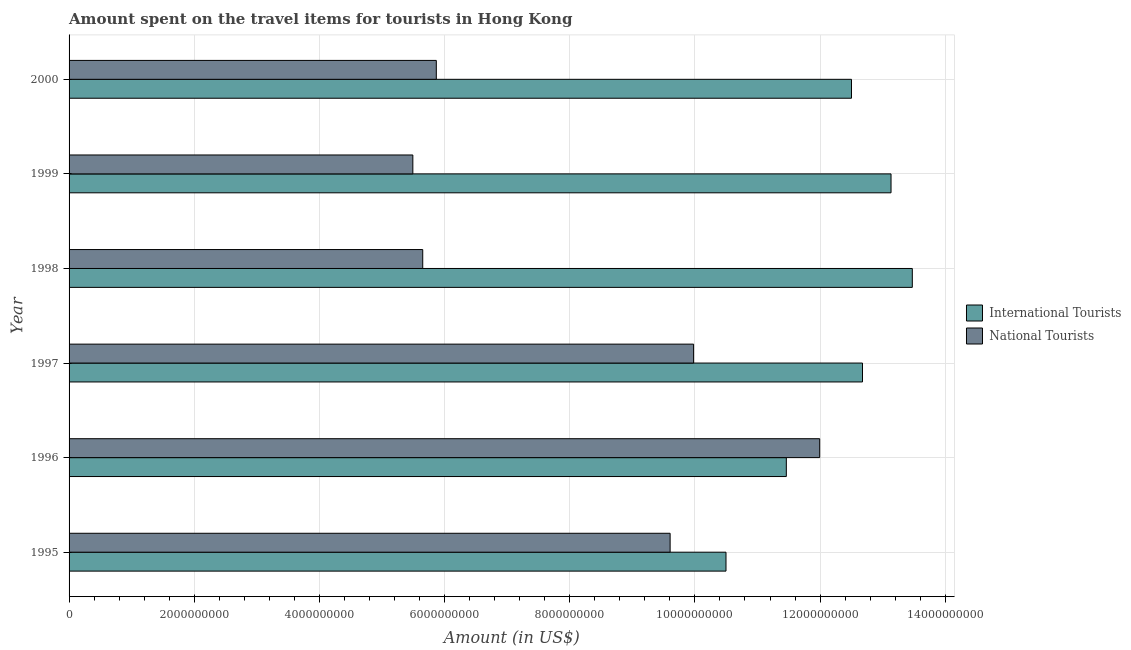Are the number of bars on each tick of the Y-axis equal?
Provide a succinct answer. Yes. How many bars are there on the 4th tick from the top?
Give a very brief answer. 2. What is the label of the 6th group of bars from the top?
Your answer should be very brief. 1995. What is the amount spent on travel items of international tourists in 1999?
Your response must be concise. 1.31e+1. Across all years, what is the maximum amount spent on travel items of national tourists?
Ensure brevity in your answer.  1.20e+1. Across all years, what is the minimum amount spent on travel items of national tourists?
Your answer should be very brief. 5.49e+09. In which year was the amount spent on travel items of national tourists maximum?
Your answer should be compact. 1996. What is the total amount spent on travel items of national tourists in the graph?
Offer a terse response. 4.86e+1. What is the difference between the amount spent on travel items of international tourists in 1999 and that in 2000?
Ensure brevity in your answer.  6.32e+08. What is the difference between the amount spent on travel items of national tourists in 1997 and the amount spent on travel items of international tourists in 2000?
Your answer should be compact. -2.52e+09. What is the average amount spent on travel items of international tourists per year?
Offer a terse response. 1.23e+1. In the year 2000, what is the difference between the amount spent on travel items of national tourists and amount spent on travel items of international tourists?
Offer a very short reply. -6.63e+09. What is the ratio of the amount spent on travel items of international tourists in 1997 to that in 1998?
Your answer should be compact. 0.94. Is the difference between the amount spent on travel items of national tourists in 1998 and 2000 greater than the difference between the amount spent on travel items of international tourists in 1998 and 2000?
Provide a succinct answer. No. What is the difference between the highest and the second highest amount spent on travel items of national tourists?
Provide a succinct answer. 2.02e+09. What is the difference between the highest and the lowest amount spent on travel items of national tourists?
Your response must be concise. 6.50e+09. In how many years, is the amount spent on travel items of international tourists greater than the average amount spent on travel items of international tourists taken over all years?
Make the answer very short. 4. What does the 2nd bar from the top in 1995 represents?
Keep it short and to the point. International Tourists. What does the 1st bar from the bottom in 1995 represents?
Keep it short and to the point. International Tourists. Are all the bars in the graph horizontal?
Your answer should be compact. Yes. How many years are there in the graph?
Offer a terse response. 6. What is the difference between two consecutive major ticks on the X-axis?
Your answer should be very brief. 2.00e+09. Are the values on the major ticks of X-axis written in scientific E-notation?
Your answer should be compact. No. Does the graph contain any zero values?
Offer a very short reply. No. Does the graph contain grids?
Make the answer very short. Yes. Where does the legend appear in the graph?
Provide a succinct answer. Center right. What is the title of the graph?
Offer a terse response. Amount spent on the travel items for tourists in Hong Kong. What is the label or title of the Y-axis?
Your response must be concise. Year. What is the Amount (in US$) of International Tourists in 1995?
Provide a short and direct response. 1.05e+1. What is the Amount (in US$) of National Tourists in 1995?
Keep it short and to the point. 9.60e+09. What is the Amount (in US$) in International Tourists in 1996?
Give a very brief answer. 1.15e+1. What is the Amount (in US$) in National Tourists in 1996?
Provide a succinct answer. 1.20e+1. What is the Amount (in US$) in International Tourists in 1997?
Your response must be concise. 1.27e+1. What is the Amount (in US$) of National Tourists in 1997?
Your answer should be very brief. 9.98e+09. What is the Amount (in US$) of International Tourists in 1998?
Provide a short and direct response. 1.35e+1. What is the Amount (in US$) of National Tourists in 1998?
Keep it short and to the point. 5.65e+09. What is the Amount (in US$) of International Tourists in 1999?
Your response must be concise. 1.31e+1. What is the Amount (in US$) in National Tourists in 1999?
Keep it short and to the point. 5.49e+09. What is the Amount (in US$) in International Tourists in 2000?
Your response must be concise. 1.25e+1. What is the Amount (in US$) in National Tourists in 2000?
Your answer should be very brief. 5.87e+09. Across all years, what is the maximum Amount (in US$) of International Tourists?
Ensure brevity in your answer.  1.35e+1. Across all years, what is the maximum Amount (in US$) in National Tourists?
Give a very brief answer. 1.20e+1. Across all years, what is the minimum Amount (in US$) in International Tourists?
Your answer should be compact. 1.05e+1. Across all years, what is the minimum Amount (in US$) of National Tourists?
Provide a succinct answer. 5.49e+09. What is the total Amount (in US$) of International Tourists in the graph?
Provide a short and direct response. 7.37e+1. What is the total Amount (in US$) of National Tourists in the graph?
Keep it short and to the point. 4.86e+1. What is the difference between the Amount (in US$) of International Tourists in 1995 and that in 1996?
Provide a succinct answer. -9.64e+08. What is the difference between the Amount (in US$) of National Tourists in 1995 and that in 1996?
Provide a succinct answer. -2.39e+09. What is the difference between the Amount (in US$) of International Tourists in 1995 and that in 1997?
Your response must be concise. -2.18e+09. What is the difference between the Amount (in US$) in National Tourists in 1995 and that in 1997?
Ensure brevity in your answer.  -3.75e+08. What is the difference between the Amount (in US$) in International Tourists in 1995 and that in 1998?
Provide a succinct answer. -2.98e+09. What is the difference between the Amount (in US$) in National Tourists in 1995 and that in 1998?
Offer a very short reply. 3.95e+09. What is the difference between the Amount (in US$) of International Tourists in 1995 and that in 1999?
Your response must be concise. -2.64e+09. What is the difference between the Amount (in US$) in National Tourists in 1995 and that in 1999?
Offer a very short reply. 4.11e+09. What is the difference between the Amount (in US$) of International Tourists in 1995 and that in 2000?
Provide a short and direct response. -2.00e+09. What is the difference between the Amount (in US$) in National Tourists in 1995 and that in 2000?
Make the answer very short. 3.74e+09. What is the difference between the Amount (in US$) of International Tourists in 1996 and that in 1997?
Make the answer very short. -1.22e+09. What is the difference between the Amount (in US$) of National Tourists in 1996 and that in 1997?
Your response must be concise. 2.02e+09. What is the difference between the Amount (in US$) of International Tourists in 1996 and that in 1998?
Make the answer very short. -2.01e+09. What is the difference between the Amount (in US$) of National Tourists in 1996 and that in 1998?
Your answer should be compact. 6.34e+09. What is the difference between the Amount (in US$) of International Tourists in 1996 and that in 1999?
Offer a very short reply. -1.67e+09. What is the difference between the Amount (in US$) in National Tourists in 1996 and that in 1999?
Your answer should be compact. 6.50e+09. What is the difference between the Amount (in US$) in International Tourists in 1996 and that in 2000?
Provide a succinct answer. -1.04e+09. What is the difference between the Amount (in US$) in National Tourists in 1996 and that in 2000?
Offer a very short reply. 6.13e+09. What is the difference between the Amount (in US$) in International Tourists in 1997 and that in 1998?
Provide a short and direct response. -7.96e+08. What is the difference between the Amount (in US$) in National Tourists in 1997 and that in 1998?
Your response must be concise. 4.33e+09. What is the difference between the Amount (in US$) in International Tourists in 1997 and that in 1999?
Provide a short and direct response. -4.56e+08. What is the difference between the Amount (in US$) in National Tourists in 1997 and that in 1999?
Keep it short and to the point. 4.49e+09. What is the difference between the Amount (in US$) in International Tourists in 1997 and that in 2000?
Offer a very short reply. 1.76e+08. What is the difference between the Amount (in US$) in National Tourists in 1997 and that in 2000?
Keep it short and to the point. 4.11e+09. What is the difference between the Amount (in US$) in International Tourists in 1998 and that in 1999?
Offer a very short reply. 3.40e+08. What is the difference between the Amount (in US$) in National Tourists in 1998 and that in 1999?
Make the answer very short. 1.58e+08. What is the difference between the Amount (in US$) in International Tourists in 1998 and that in 2000?
Provide a succinct answer. 9.72e+08. What is the difference between the Amount (in US$) of National Tourists in 1998 and that in 2000?
Ensure brevity in your answer.  -2.17e+08. What is the difference between the Amount (in US$) in International Tourists in 1999 and that in 2000?
Give a very brief answer. 6.32e+08. What is the difference between the Amount (in US$) of National Tourists in 1999 and that in 2000?
Your response must be concise. -3.75e+08. What is the difference between the Amount (in US$) in International Tourists in 1995 and the Amount (in US$) in National Tourists in 1996?
Make the answer very short. -1.50e+09. What is the difference between the Amount (in US$) in International Tourists in 1995 and the Amount (in US$) in National Tourists in 1997?
Keep it short and to the point. 5.18e+08. What is the difference between the Amount (in US$) in International Tourists in 1995 and the Amount (in US$) in National Tourists in 1998?
Give a very brief answer. 4.85e+09. What is the difference between the Amount (in US$) of International Tourists in 1995 and the Amount (in US$) of National Tourists in 1999?
Provide a short and direct response. 5.00e+09. What is the difference between the Amount (in US$) of International Tourists in 1995 and the Amount (in US$) of National Tourists in 2000?
Your response must be concise. 4.63e+09. What is the difference between the Amount (in US$) in International Tourists in 1996 and the Amount (in US$) in National Tourists in 1997?
Make the answer very short. 1.48e+09. What is the difference between the Amount (in US$) of International Tourists in 1996 and the Amount (in US$) of National Tourists in 1998?
Ensure brevity in your answer.  5.81e+09. What is the difference between the Amount (in US$) of International Tourists in 1996 and the Amount (in US$) of National Tourists in 1999?
Ensure brevity in your answer.  5.97e+09. What is the difference between the Amount (in US$) of International Tourists in 1996 and the Amount (in US$) of National Tourists in 2000?
Your answer should be compact. 5.59e+09. What is the difference between the Amount (in US$) in International Tourists in 1997 and the Amount (in US$) in National Tourists in 1998?
Offer a terse response. 7.03e+09. What is the difference between the Amount (in US$) of International Tourists in 1997 and the Amount (in US$) of National Tourists in 1999?
Provide a short and direct response. 7.18e+09. What is the difference between the Amount (in US$) of International Tourists in 1997 and the Amount (in US$) of National Tourists in 2000?
Provide a succinct answer. 6.81e+09. What is the difference between the Amount (in US$) of International Tourists in 1998 and the Amount (in US$) of National Tourists in 1999?
Offer a terse response. 7.98e+09. What is the difference between the Amount (in US$) in International Tourists in 1998 and the Amount (in US$) in National Tourists in 2000?
Give a very brief answer. 7.61e+09. What is the difference between the Amount (in US$) in International Tourists in 1999 and the Amount (in US$) in National Tourists in 2000?
Provide a succinct answer. 7.27e+09. What is the average Amount (in US$) in International Tourists per year?
Keep it short and to the point. 1.23e+1. What is the average Amount (in US$) of National Tourists per year?
Offer a very short reply. 8.10e+09. In the year 1995, what is the difference between the Amount (in US$) of International Tourists and Amount (in US$) of National Tourists?
Provide a succinct answer. 8.93e+08. In the year 1996, what is the difference between the Amount (in US$) of International Tourists and Amount (in US$) of National Tourists?
Offer a very short reply. -5.33e+08. In the year 1997, what is the difference between the Amount (in US$) of International Tourists and Amount (in US$) of National Tourists?
Offer a terse response. 2.70e+09. In the year 1998, what is the difference between the Amount (in US$) in International Tourists and Amount (in US$) in National Tourists?
Ensure brevity in your answer.  7.82e+09. In the year 1999, what is the difference between the Amount (in US$) of International Tourists and Amount (in US$) of National Tourists?
Offer a very short reply. 7.64e+09. In the year 2000, what is the difference between the Amount (in US$) of International Tourists and Amount (in US$) of National Tourists?
Give a very brief answer. 6.63e+09. What is the ratio of the Amount (in US$) in International Tourists in 1995 to that in 1996?
Provide a succinct answer. 0.92. What is the ratio of the Amount (in US$) of National Tourists in 1995 to that in 1996?
Your answer should be compact. 0.8. What is the ratio of the Amount (in US$) of International Tourists in 1995 to that in 1997?
Your response must be concise. 0.83. What is the ratio of the Amount (in US$) in National Tourists in 1995 to that in 1997?
Give a very brief answer. 0.96. What is the ratio of the Amount (in US$) in International Tourists in 1995 to that in 1998?
Make the answer very short. 0.78. What is the ratio of the Amount (in US$) in National Tourists in 1995 to that in 1998?
Keep it short and to the point. 1.7. What is the ratio of the Amount (in US$) in International Tourists in 1995 to that in 1999?
Give a very brief answer. 0.8. What is the ratio of the Amount (in US$) of National Tourists in 1995 to that in 1999?
Make the answer very short. 1.75. What is the ratio of the Amount (in US$) in International Tourists in 1995 to that in 2000?
Provide a succinct answer. 0.84. What is the ratio of the Amount (in US$) in National Tourists in 1995 to that in 2000?
Make the answer very short. 1.64. What is the ratio of the Amount (in US$) of International Tourists in 1996 to that in 1997?
Keep it short and to the point. 0.9. What is the ratio of the Amount (in US$) of National Tourists in 1996 to that in 1997?
Offer a very short reply. 1.2. What is the ratio of the Amount (in US$) of International Tourists in 1996 to that in 1998?
Make the answer very short. 0.85. What is the ratio of the Amount (in US$) of National Tourists in 1996 to that in 1998?
Provide a short and direct response. 2.12. What is the ratio of the Amount (in US$) in International Tourists in 1996 to that in 1999?
Your answer should be very brief. 0.87. What is the ratio of the Amount (in US$) of National Tourists in 1996 to that in 1999?
Ensure brevity in your answer.  2.18. What is the ratio of the Amount (in US$) of International Tourists in 1996 to that in 2000?
Provide a succinct answer. 0.92. What is the ratio of the Amount (in US$) of National Tourists in 1996 to that in 2000?
Offer a very short reply. 2.04. What is the ratio of the Amount (in US$) in International Tourists in 1997 to that in 1998?
Make the answer very short. 0.94. What is the ratio of the Amount (in US$) of National Tourists in 1997 to that in 1998?
Provide a short and direct response. 1.77. What is the ratio of the Amount (in US$) in International Tourists in 1997 to that in 1999?
Provide a short and direct response. 0.97. What is the ratio of the Amount (in US$) in National Tourists in 1997 to that in 1999?
Keep it short and to the point. 1.82. What is the ratio of the Amount (in US$) in International Tourists in 1997 to that in 2000?
Provide a succinct answer. 1.01. What is the ratio of the Amount (in US$) in National Tourists in 1997 to that in 2000?
Offer a terse response. 1.7. What is the ratio of the Amount (in US$) of International Tourists in 1998 to that in 1999?
Provide a short and direct response. 1.03. What is the ratio of the Amount (in US$) in National Tourists in 1998 to that in 1999?
Give a very brief answer. 1.03. What is the ratio of the Amount (in US$) in International Tourists in 1998 to that in 2000?
Your answer should be compact. 1.08. What is the ratio of the Amount (in US$) of National Tourists in 1998 to that in 2000?
Ensure brevity in your answer.  0.96. What is the ratio of the Amount (in US$) in International Tourists in 1999 to that in 2000?
Make the answer very short. 1.05. What is the ratio of the Amount (in US$) in National Tourists in 1999 to that in 2000?
Offer a terse response. 0.94. What is the difference between the highest and the second highest Amount (in US$) of International Tourists?
Give a very brief answer. 3.40e+08. What is the difference between the highest and the second highest Amount (in US$) of National Tourists?
Offer a very short reply. 2.02e+09. What is the difference between the highest and the lowest Amount (in US$) of International Tourists?
Ensure brevity in your answer.  2.98e+09. What is the difference between the highest and the lowest Amount (in US$) in National Tourists?
Make the answer very short. 6.50e+09. 